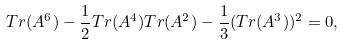Convert formula to latex. <formula><loc_0><loc_0><loc_500><loc_500>T r ( A ^ { 6 } ) - \frac { 1 } { 2 } T r ( A ^ { 4 } ) T r ( A ^ { 2 } ) - \frac { 1 } { 3 } ( T r ( A ^ { 3 } ) ) ^ { 2 } = 0 ,</formula> 